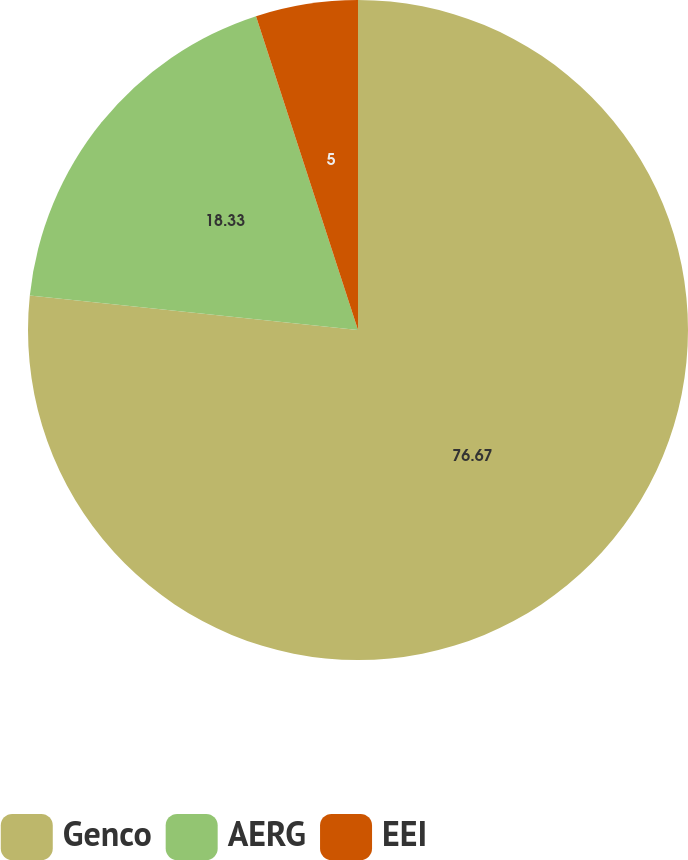Convert chart to OTSL. <chart><loc_0><loc_0><loc_500><loc_500><pie_chart><fcel>Genco<fcel>AERG<fcel>EEI<nl><fcel>76.67%<fcel>18.33%<fcel>5.0%<nl></chart> 